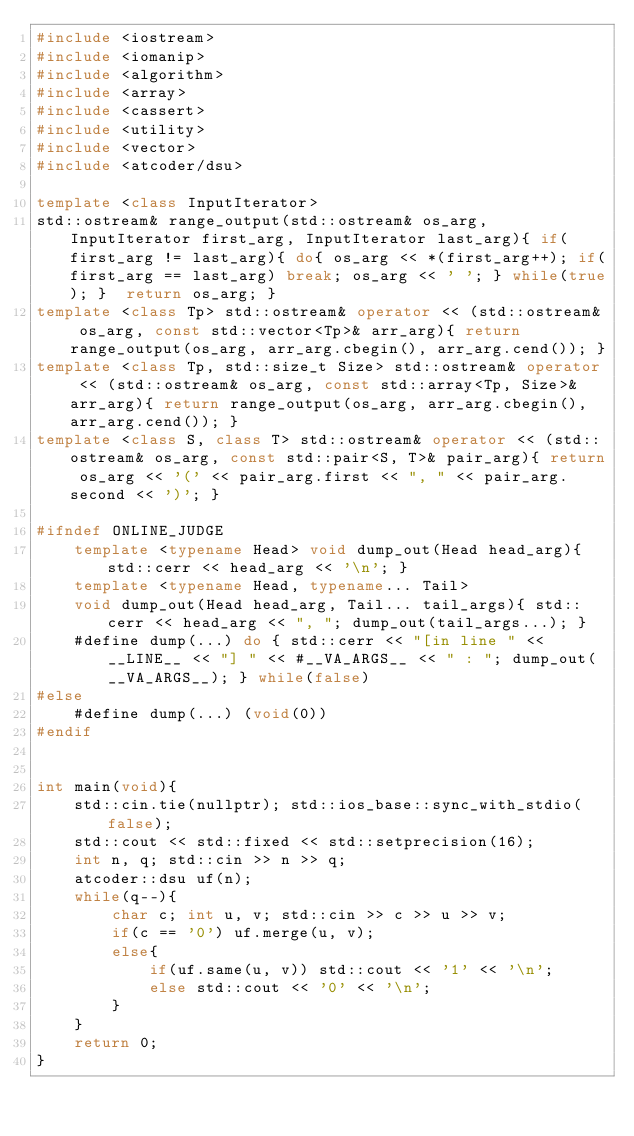<code> <loc_0><loc_0><loc_500><loc_500><_C++_>#include <iostream>
#include <iomanip>
#include <algorithm>
#include <array>
#include <cassert>
#include <utility>
#include <vector>
#include <atcoder/dsu>

template <class InputIterator>
std::ostream& range_output(std::ostream& os_arg, InputIterator first_arg, InputIterator last_arg){ if(first_arg != last_arg){ do{ os_arg << *(first_arg++); if(first_arg == last_arg) break; os_arg << ' '; } while(true); }  return os_arg; }
template <class Tp> std::ostream& operator << (std::ostream& os_arg, const std::vector<Tp>& arr_arg){ return range_output(os_arg, arr_arg.cbegin(), arr_arg.cend()); }
template <class Tp, std::size_t Size> std::ostream& operator << (std::ostream& os_arg, const std::array<Tp, Size>& arr_arg){ return range_output(os_arg, arr_arg.cbegin(), arr_arg.cend()); }
template <class S, class T> std::ostream& operator << (std::ostream& os_arg, const std::pair<S, T>& pair_arg){ return os_arg << '(' << pair_arg.first << ", " << pair_arg.second << ')'; }

#ifndef ONLINE_JUDGE
    template <typename Head> void dump_out(Head head_arg){ std::cerr << head_arg << '\n'; }
    template <typename Head, typename... Tail>
    void dump_out(Head head_arg, Tail... tail_args){ std::cerr << head_arg << ", "; dump_out(tail_args...); }
    #define dump(...) do { std::cerr << "[in line " << __LINE__ << "] " << #__VA_ARGS__ << " : "; dump_out(__VA_ARGS__); } while(false)
#else
    #define dump(...) (void(0))
#endif


int main(void){
    std::cin.tie(nullptr); std::ios_base::sync_with_stdio(false); 
    std::cout << std::fixed << std::setprecision(16);
    int n, q; std::cin >> n >> q;
    atcoder::dsu uf(n);
    while(q--){
        char c; int u, v; std::cin >> c >> u >> v;
        if(c == '0') uf.merge(u, v);
        else{
            if(uf.same(u, v)) std::cout << '1' << '\n';
            else std::cout << '0' << '\n';
        }
    }
    return 0;
}</code> 